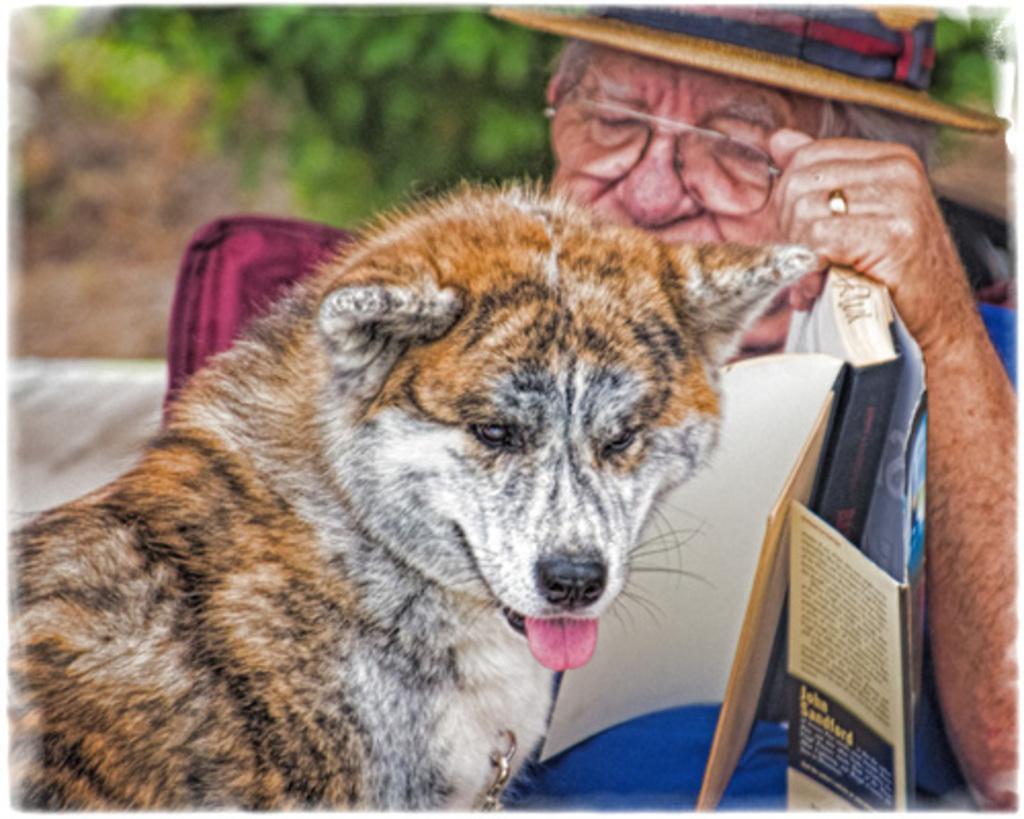Could you give a brief overview of what you see in this image? There is a dog and a man in the middle of this image. We can see greenery in the background. 